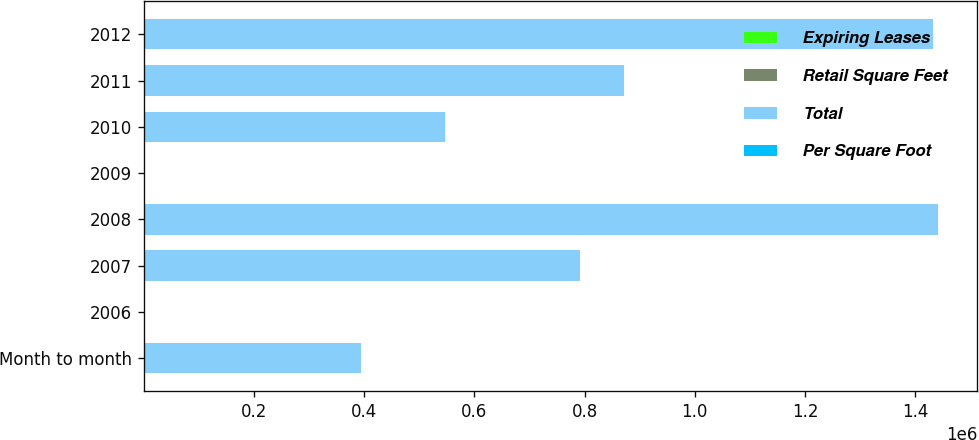Convert chart. <chart><loc_0><loc_0><loc_500><loc_500><stacked_bar_chart><ecel><fcel>Month to month<fcel>2006<fcel>2007<fcel>2008<fcel>2009<fcel>2010<fcel>2011<fcel>2012<nl><fcel>Expiring Leases<fcel>6<fcel>8<fcel>3<fcel>8<fcel>4<fcel>4<fcel>4<fcel>3<nl><fcel>Retail Square Feet<fcel>0.8<fcel>6.4<fcel>0.5<fcel>3.4<fcel>2.4<fcel>0.9<fcel>2.6<fcel>6.1<nl><fcel>Total<fcel>395000<fcel>8<fcel>792000<fcel>1.441e+06<fcel>8<fcel>546000<fcel>872000<fcel>1.433e+06<nl><fcel>Per Square Foot<fcel>65.83<fcel>54.47<fcel>198<fcel>57.64<fcel>164.56<fcel>91<fcel>45.89<fcel>31.84<nl></chart> 